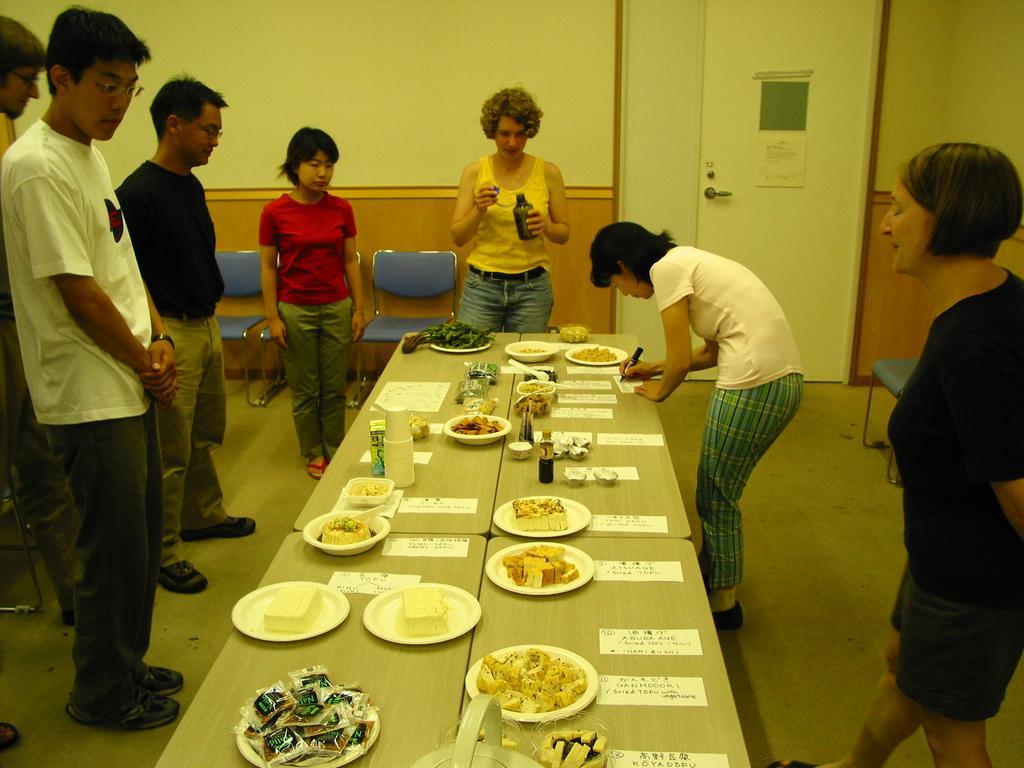Could you give a brief overview of what you see in this image? In the center of the picture there are tables, on the tables there are plates, bowls, papers, bottle and various food items. On the left there are people standing. In the background there are people, chairs, wall and door. On the right there are people and chairs. 